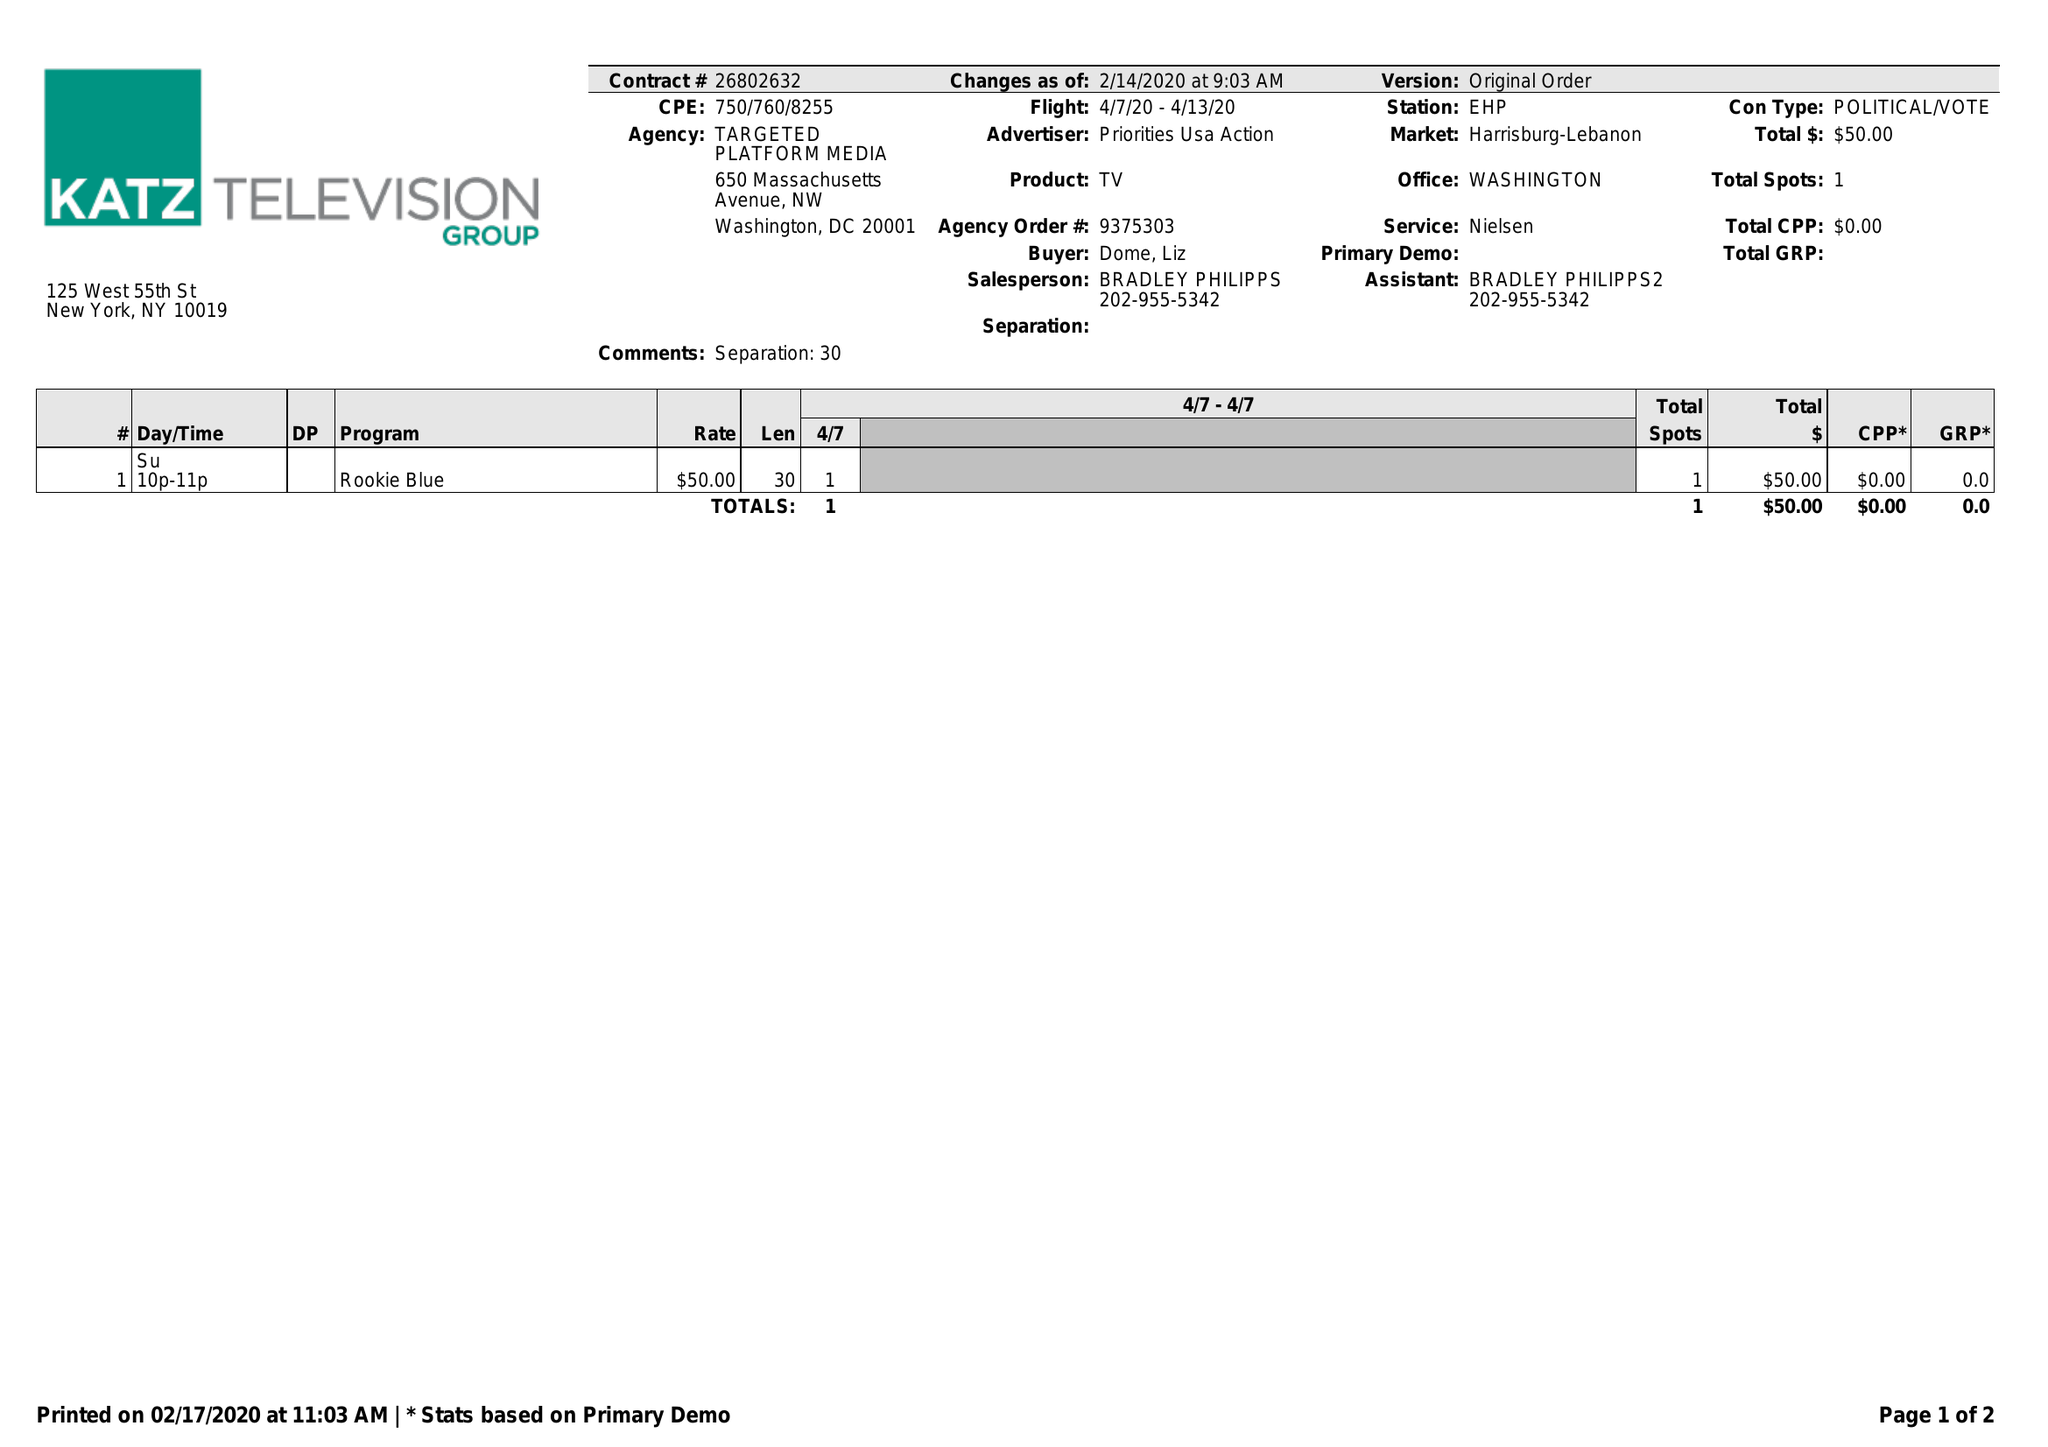What is the value for the gross_amount?
Answer the question using a single word or phrase. 50.00 